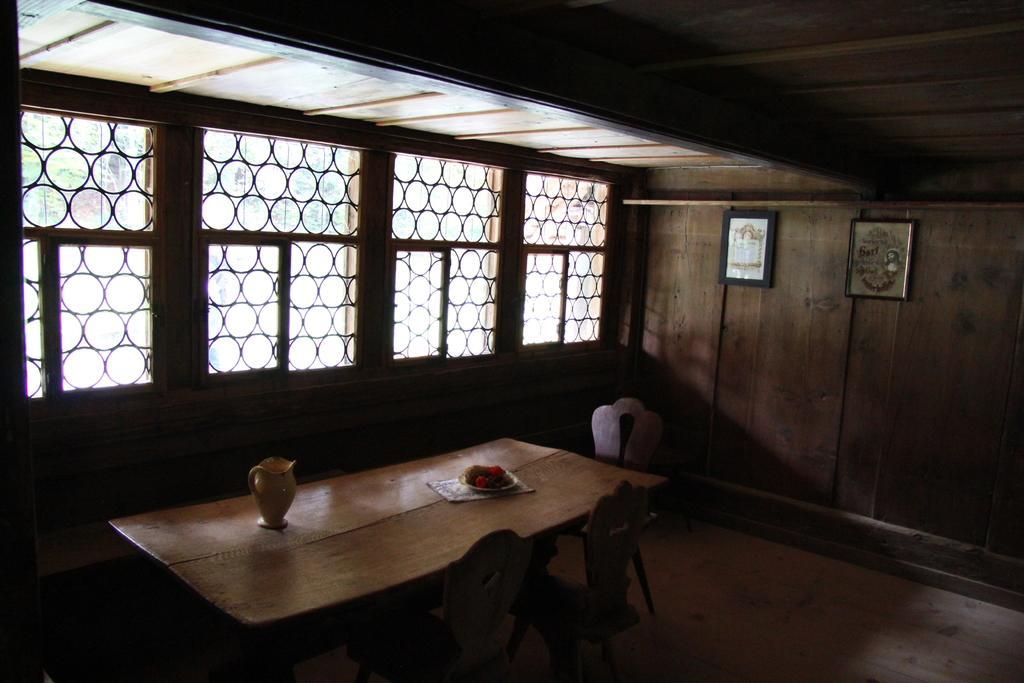How would you summarize this image in a sentence or two? In this picture, we see a table on which jug and a bowl are placed. Beside that, we see chairs. On the right side, we see a wooden wall on which photo frames are placed. On the left side, we see windows from which we can see trees. 